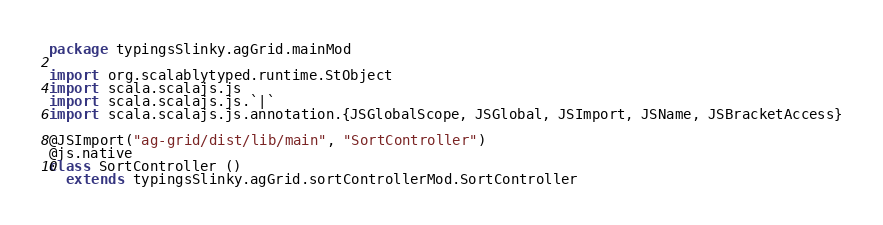<code> <loc_0><loc_0><loc_500><loc_500><_Scala_>package typingsSlinky.agGrid.mainMod

import org.scalablytyped.runtime.StObject
import scala.scalajs.js
import scala.scalajs.js.`|`
import scala.scalajs.js.annotation.{JSGlobalScope, JSGlobal, JSImport, JSName, JSBracketAccess}

@JSImport("ag-grid/dist/lib/main", "SortController")
@js.native
class SortController ()
  extends typingsSlinky.agGrid.sortControllerMod.SortController</code> 